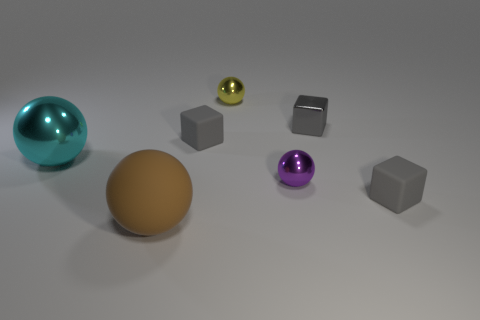Can you describe the objects in the image and their colors? Certainly, the image displays a collection of geometric objects. There's a large teal sphere, a small golden sphere, and a tiny olive sphere. Additionally, there are three cubes; two are a neutral gray, and one has a metallic sheen reflecting its environment. Are there any patterns or symmetry in how the objects are arranged? The arrangement appears to be random without any clear pattern or symmetry. The objects are scattered without any discernible order, possibly suggesting a freeform or abstract concept. 